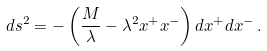Convert formula to latex. <formula><loc_0><loc_0><loc_500><loc_500>d s ^ { 2 } = - \left ( \frac { M } { \lambda } - \lambda ^ { 2 } x ^ { + } x ^ { - } \right ) d x ^ { + } d x ^ { - } \, .</formula> 